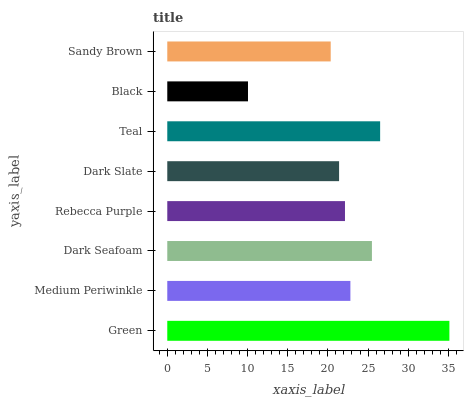Is Black the minimum?
Answer yes or no. Yes. Is Green the maximum?
Answer yes or no. Yes. Is Medium Periwinkle the minimum?
Answer yes or no. No. Is Medium Periwinkle the maximum?
Answer yes or no. No. Is Green greater than Medium Periwinkle?
Answer yes or no. Yes. Is Medium Periwinkle less than Green?
Answer yes or no. Yes. Is Medium Periwinkle greater than Green?
Answer yes or no. No. Is Green less than Medium Periwinkle?
Answer yes or no. No. Is Medium Periwinkle the high median?
Answer yes or no. Yes. Is Rebecca Purple the low median?
Answer yes or no. Yes. Is Rebecca Purple the high median?
Answer yes or no. No. Is Teal the low median?
Answer yes or no. No. 